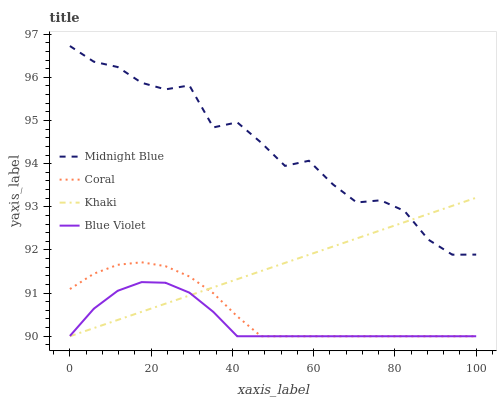Does Blue Violet have the minimum area under the curve?
Answer yes or no. Yes. Does Midnight Blue have the maximum area under the curve?
Answer yes or no. Yes. Does Khaki have the minimum area under the curve?
Answer yes or no. No. Does Khaki have the maximum area under the curve?
Answer yes or no. No. Is Khaki the smoothest?
Answer yes or no. Yes. Is Midnight Blue the roughest?
Answer yes or no. Yes. Is Midnight Blue the smoothest?
Answer yes or no. No. Is Khaki the roughest?
Answer yes or no. No. Does Coral have the lowest value?
Answer yes or no. Yes. Does Midnight Blue have the lowest value?
Answer yes or no. No. Does Midnight Blue have the highest value?
Answer yes or no. Yes. Does Khaki have the highest value?
Answer yes or no. No. Is Coral less than Midnight Blue?
Answer yes or no. Yes. Is Midnight Blue greater than Coral?
Answer yes or no. Yes. Does Khaki intersect Coral?
Answer yes or no. Yes. Is Khaki less than Coral?
Answer yes or no. No. Is Khaki greater than Coral?
Answer yes or no. No. Does Coral intersect Midnight Blue?
Answer yes or no. No. 